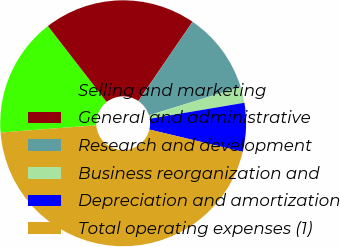Convert chart. <chart><loc_0><loc_0><loc_500><loc_500><pie_chart><fcel>Selling and marketing<fcel>General and administrative<fcel>Research and development<fcel>Business reorganization and<fcel>Depreciation and amortization<fcel>Total operating expenses (1)<nl><fcel>15.72%<fcel>20.02%<fcel>10.69%<fcel>2.1%<fcel>6.4%<fcel>45.06%<nl></chart> 